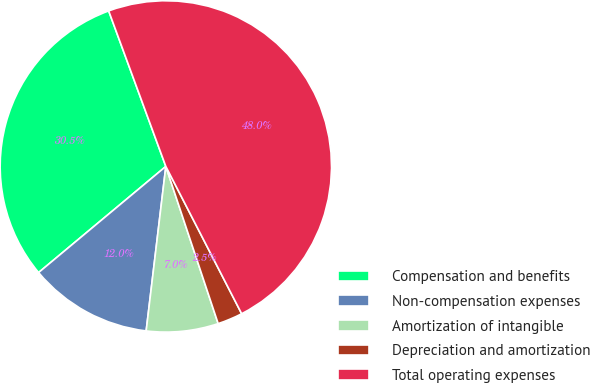<chart> <loc_0><loc_0><loc_500><loc_500><pie_chart><fcel>Compensation and benefits<fcel>Non-compensation expenses<fcel>Amortization of intangible<fcel>Depreciation and amortization<fcel>Total operating expenses<nl><fcel>30.46%<fcel>12.04%<fcel>7.01%<fcel>2.45%<fcel>48.04%<nl></chart> 